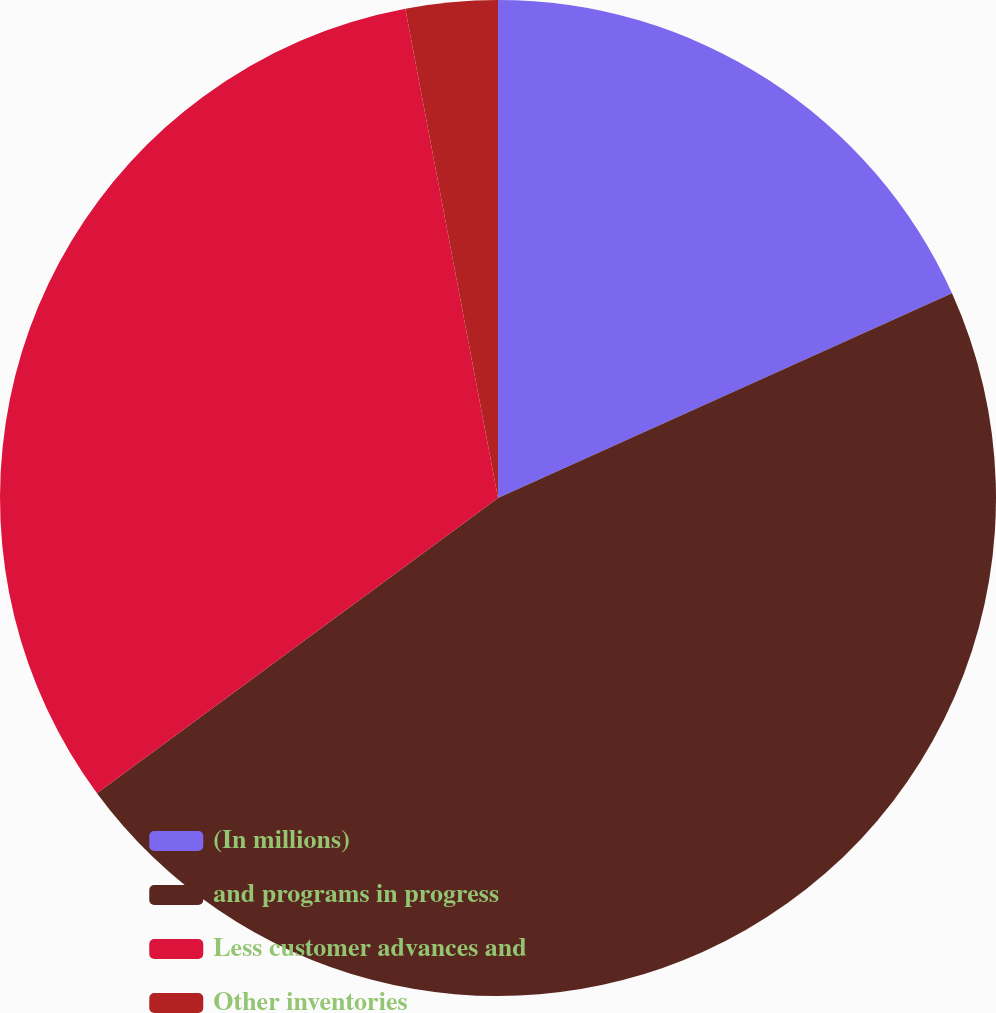Convert chart. <chart><loc_0><loc_0><loc_500><loc_500><pie_chart><fcel>(In millions)<fcel>and programs in progress<fcel>Less customer advances and<fcel>Other inventories<nl><fcel>18.26%<fcel>46.64%<fcel>32.12%<fcel>2.98%<nl></chart> 